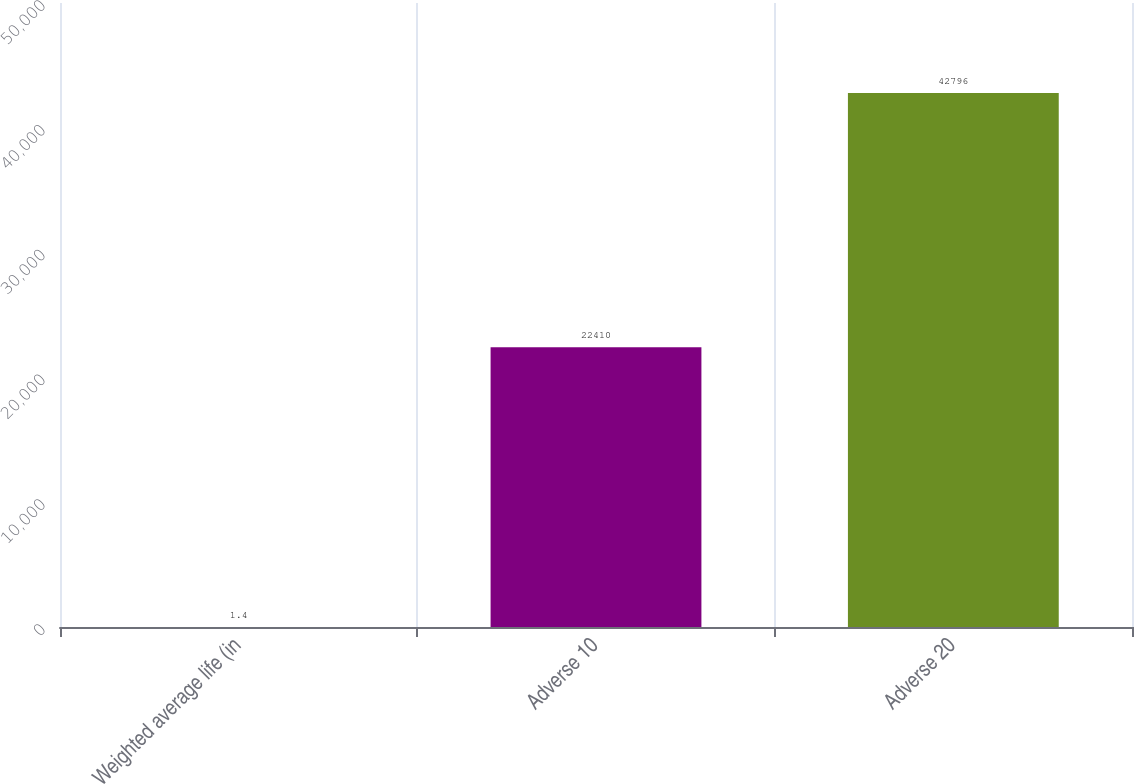Convert chart to OTSL. <chart><loc_0><loc_0><loc_500><loc_500><bar_chart><fcel>Weighted average life (in<fcel>Adverse 10<fcel>Adverse 20<nl><fcel>1.4<fcel>22410<fcel>42796<nl></chart> 